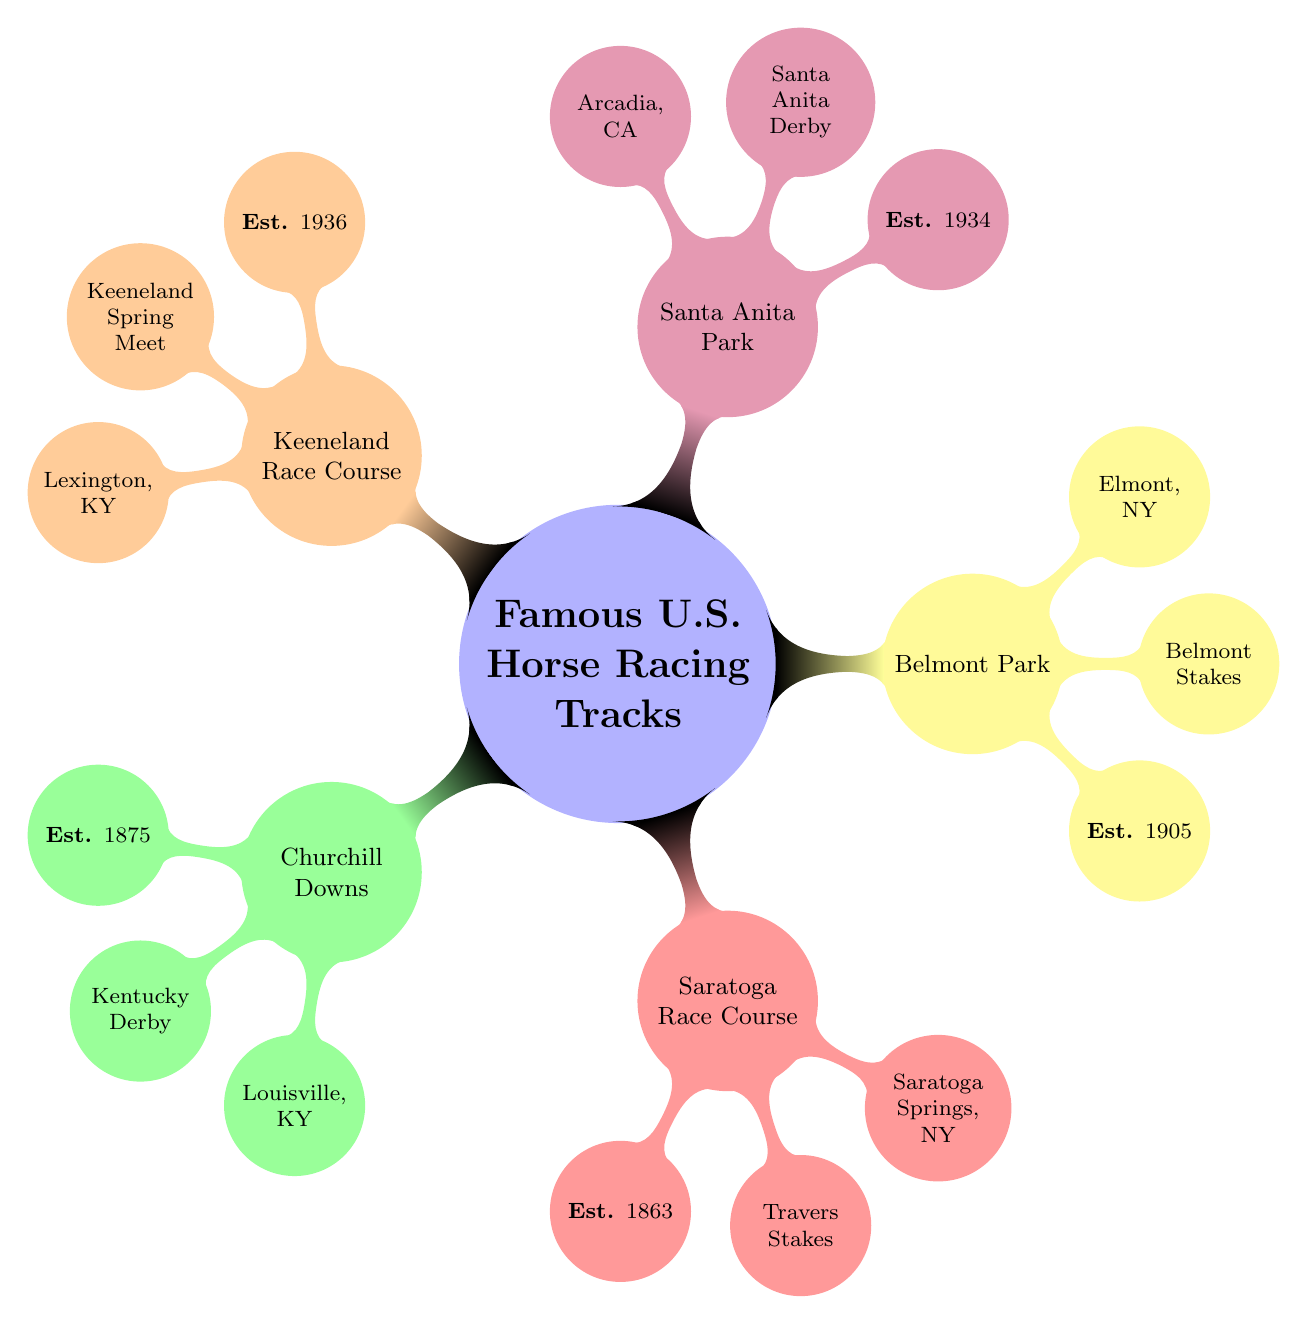What year was Churchill Downs established? The node for Churchill Downs states "Est. 1875," indicating that it was established in the year 1875.
Answer: 1875 What is the famous race held at Belmont Park? The Belmont Park node specifically notes "Belmont Stakes," which is identified as the famous race associated with that track.
Answer: Belmont Stakes Where is Santa Anita Park located? The node for Santa Anita Park lists "Arcadia, CA" as its location, providing the specific city and state.
Answer: Arcadia, CA Which horse racing track was established first, Saratoga Race Course or Keeneland Race Course? By comparing the established years in the diagram, Saratoga Race Course shows "Est. 1863" while Keeneland Race Course shows "Est. 1936." Therefore, Saratoga Race Course was established first.
Answer: Saratoga Race Course What notable event is associated with Keeneland Race Course? In the Keeneland Race Course node, it clearly states "Keeneland Spring Meet" as the notable event tied to this track.
Answer: Keeneland Spring Meet How many iconic racing locations are shown in the diagram? The diagram has five main branches representing the iconic locations of horse racing tracks, therefore counting them gives the total number of locations.
Answer: 5 Which track is located in Louisville, Kentucky? The node for Churchill Downs mentions "Louisville, KY" as its location, identifying it as the track in that city.
Answer: Churchill Downs Which racing track is known for hosting the Travers Stakes? The node labeled Saratoga Race Course notes "Travers Stakes" as a notable event, linking it directly to this track.
Answer: Saratoga Race Course Which of these tracks is the newest, based on the establishment year? By comparing the "Established" years of each node, Santa Anita Park with "Est. 1934" and Keeneland Race Course with "Est. 1936," Keeneland is the newest of the five tracks.
Answer: Keeneland Race Course 